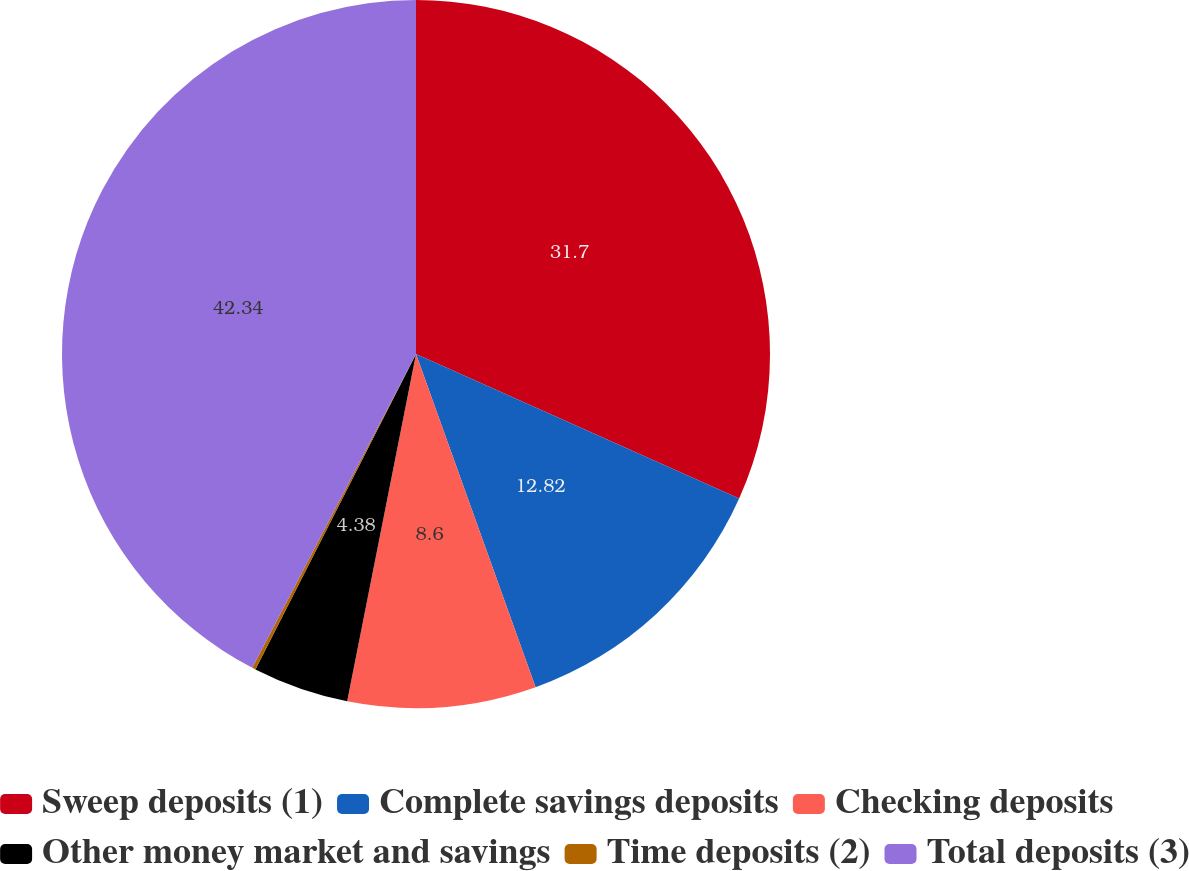Convert chart. <chart><loc_0><loc_0><loc_500><loc_500><pie_chart><fcel>Sweep deposits (1)<fcel>Complete savings deposits<fcel>Checking deposits<fcel>Other money market and savings<fcel>Time deposits (2)<fcel>Total deposits (3)<nl><fcel>31.7%<fcel>12.82%<fcel>8.6%<fcel>4.38%<fcel>0.16%<fcel>42.35%<nl></chart> 